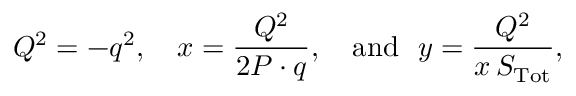Convert formula to latex. <formula><loc_0><loc_0><loc_500><loc_500>Q ^ { 2 } = - q ^ { 2 } , x = \frac { Q ^ { 2 } } { 2 P \cdot q } , a n d y = \frac { Q ^ { 2 } } { x \, S _ { T o t } } ,</formula> 